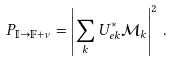<formula> <loc_0><loc_0><loc_500><loc_500>P _ { \mathbb { I } \to \mathbb { F } + \nu } = \left | \sum _ { k } U _ { e k } ^ { * } \mathcal { M } _ { k } \right | ^ { 2 } \, .</formula> 